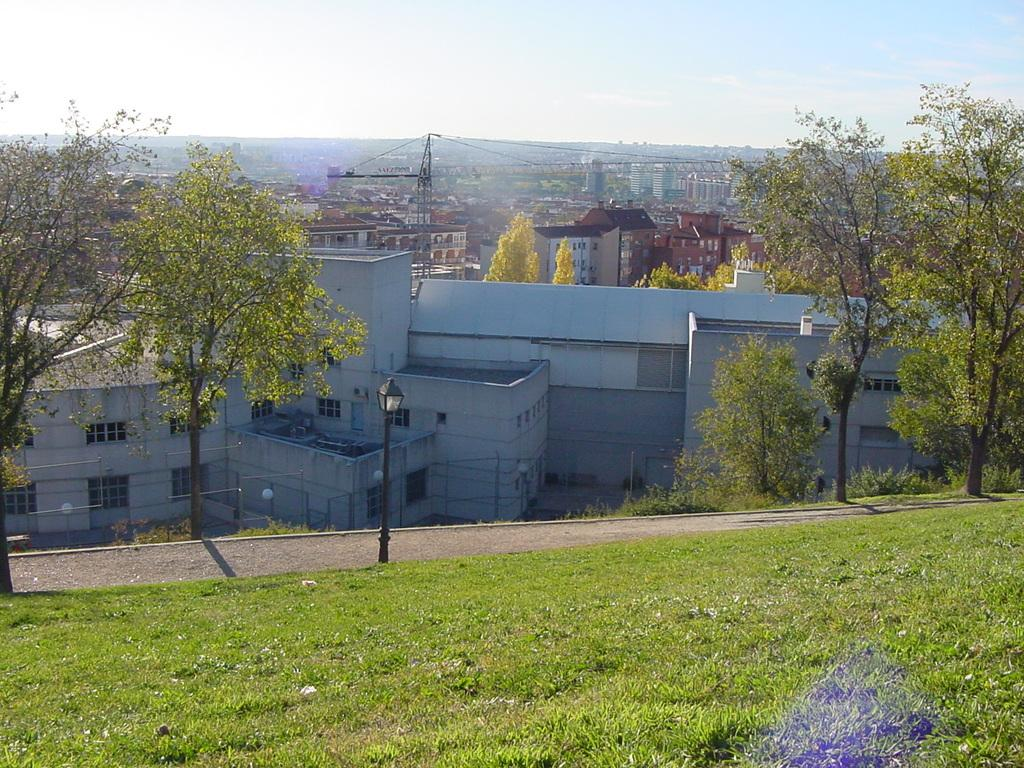What type of structures can be seen in the image? There are buildings in the image. What other natural elements are present in the image? There are trees and grass visible in the image. What man-made objects can be seen in the image besides buildings? There are poles and a crane in the image. What is visible at the top of the image? The sky is visible at the top of the image. How does the crane say good-bye to the buildings in the image? The crane does not say good-bye in the image; it is a stationary object. What is the stomach of the tree in the image? There is no stomach mentioned in the image, as trees do not have stomachs. 